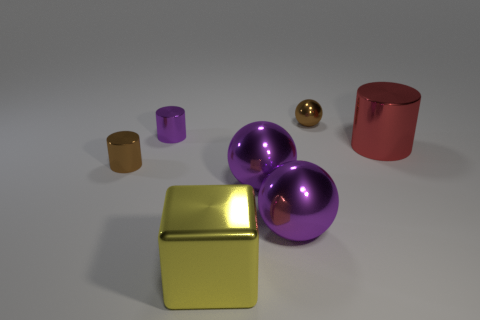Subtract all small shiny cylinders. How many cylinders are left? 1 Add 1 large red objects. How many objects exist? 8 Subtract all brown spheres. How many spheres are left? 2 Subtract all gray balls. Subtract all brown cylinders. How many balls are left? 3 Subtract all blue spheres. How many blue blocks are left? 0 Subtract all big cyan balls. Subtract all large metal cubes. How many objects are left? 6 Add 7 big yellow things. How many big yellow things are left? 8 Add 2 brown shiny things. How many brown shiny things exist? 4 Subtract 0 blue cylinders. How many objects are left? 7 Subtract all spheres. How many objects are left? 4 